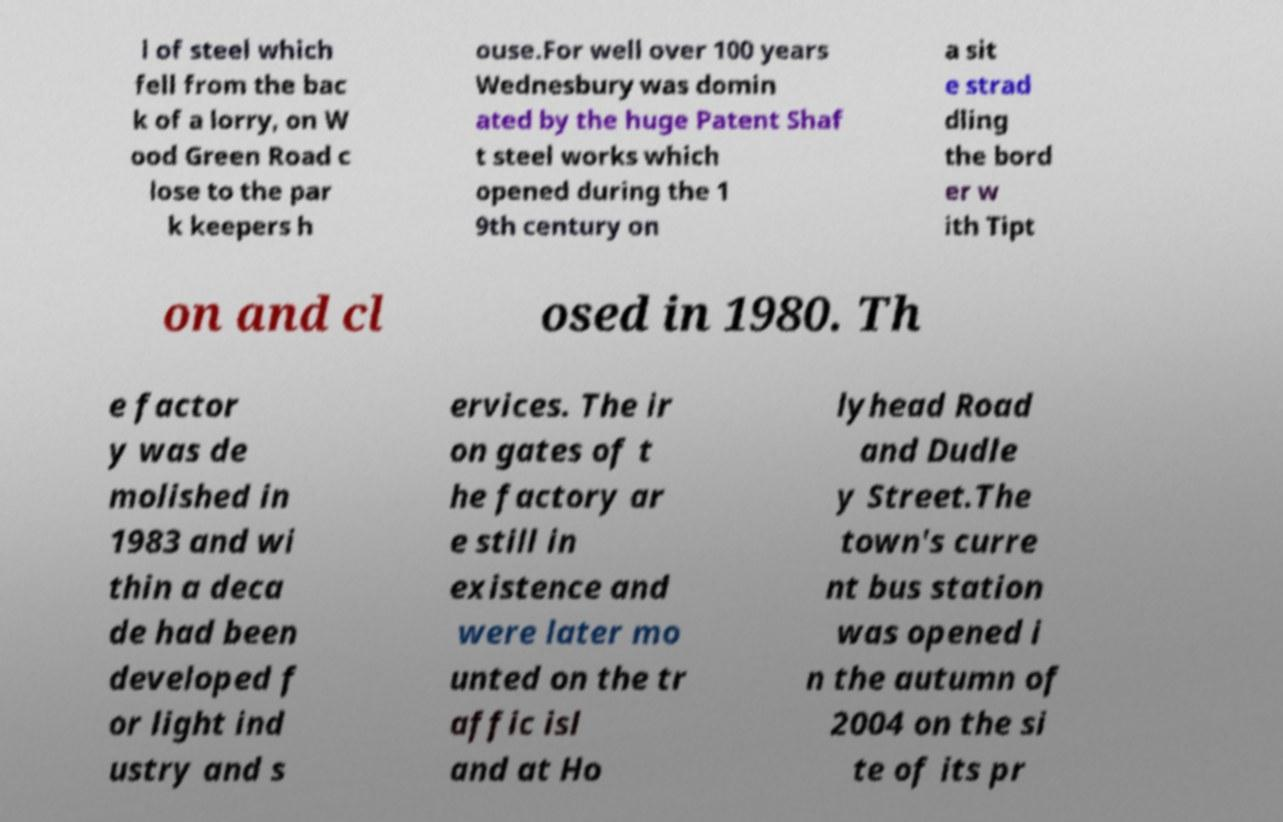Can you accurately transcribe the text from the provided image for me? l of steel which fell from the bac k of a lorry, on W ood Green Road c lose to the par k keepers h ouse.For well over 100 years Wednesbury was domin ated by the huge Patent Shaf t steel works which opened during the 1 9th century on a sit e strad dling the bord er w ith Tipt on and cl osed in 1980. Th e factor y was de molished in 1983 and wi thin a deca de had been developed f or light ind ustry and s ervices. The ir on gates of t he factory ar e still in existence and were later mo unted on the tr affic isl and at Ho lyhead Road and Dudle y Street.The town's curre nt bus station was opened i n the autumn of 2004 on the si te of its pr 